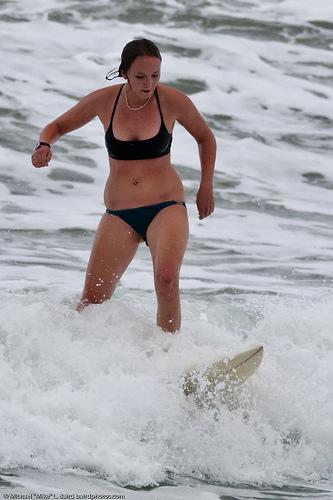Question: who is on the surfboard?
Choices:
A. An old man.
B. A woman.
C. Young girl.
D. Young boy.
Answer with the letter. Answer: B Question: how many people in photo?
Choices:
A. 12.
B. 13.
C. One woman.
D. 5.
Answer with the letter. Answer: C Question: what color is surfboard?
Choices:
A. Teal.
B. Purple.
C. White.
D. Neon.
Answer with the letter. Answer: C Question: what is the lady on?
Choices:
A. Boogie board.
B. Body board.
C. Skateboard.
D. Surfboard.
Answer with the letter. Answer: D 